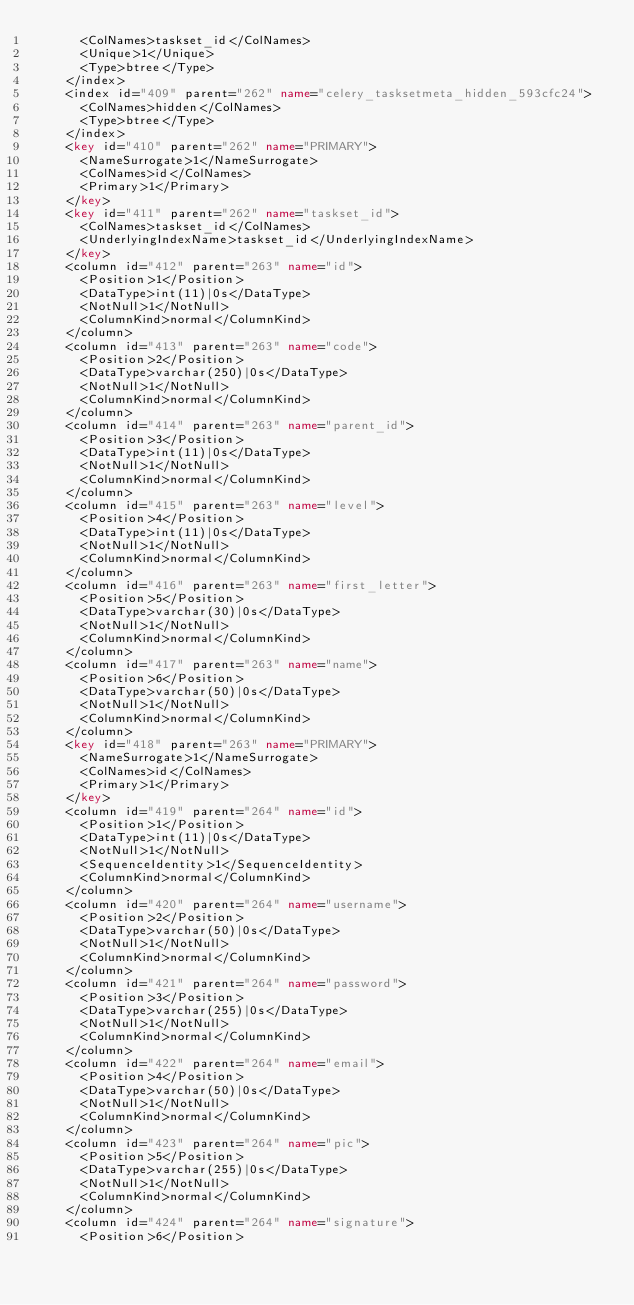Convert code to text. <code><loc_0><loc_0><loc_500><loc_500><_XML_>      <ColNames>taskset_id</ColNames>
      <Unique>1</Unique>
      <Type>btree</Type>
    </index>
    <index id="409" parent="262" name="celery_tasksetmeta_hidden_593cfc24">
      <ColNames>hidden</ColNames>
      <Type>btree</Type>
    </index>
    <key id="410" parent="262" name="PRIMARY">
      <NameSurrogate>1</NameSurrogate>
      <ColNames>id</ColNames>
      <Primary>1</Primary>
    </key>
    <key id="411" parent="262" name="taskset_id">
      <ColNames>taskset_id</ColNames>
      <UnderlyingIndexName>taskset_id</UnderlyingIndexName>
    </key>
    <column id="412" parent="263" name="id">
      <Position>1</Position>
      <DataType>int(11)|0s</DataType>
      <NotNull>1</NotNull>
      <ColumnKind>normal</ColumnKind>
    </column>
    <column id="413" parent="263" name="code">
      <Position>2</Position>
      <DataType>varchar(250)|0s</DataType>
      <NotNull>1</NotNull>
      <ColumnKind>normal</ColumnKind>
    </column>
    <column id="414" parent="263" name="parent_id">
      <Position>3</Position>
      <DataType>int(11)|0s</DataType>
      <NotNull>1</NotNull>
      <ColumnKind>normal</ColumnKind>
    </column>
    <column id="415" parent="263" name="level">
      <Position>4</Position>
      <DataType>int(11)|0s</DataType>
      <NotNull>1</NotNull>
      <ColumnKind>normal</ColumnKind>
    </column>
    <column id="416" parent="263" name="first_letter">
      <Position>5</Position>
      <DataType>varchar(30)|0s</DataType>
      <NotNull>1</NotNull>
      <ColumnKind>normal</ColumnKind>
    </column>
    <column id="417" parent="263" name="name">
      <Position>6</Position>
      <DataType>varchar(50)|0s</DataType>
      <NotNull>1</NotNull>
      <ColumnKind>normal</ColumnKind>
    </column>
    <key id="418" parent="263" name="PRIMARY">
      <NameSurrogate>1</NameSurrogate>
      <ColNames>id</ColNames>
      <Primary>1</Primary>
    </key>
    <column id="419" parent="264" name="id">
      <Position>1</Position>
      <DataType>int(11)|0s</DataType>
      <NotNull>1</NotNull>
      <SequenceIdentity>1</SequenceIdentity>
      <ColumnKind>normal</ColumnKind>
    </column>
    <column id="420" parent="264" name="username">
      <Position>2</Position>
      <DataType>varchar(50)|0s</DataType>
      <NotNull>1</NotNull>
      <ColumnKind>normal</ColumnKind>
    </column>
    <column id="421" parent="264" name="password">
      <Position>3</Position>
      <DataType>varchar(255)|0s</DataType>
      <NotNull>1</NotNull>
      <ColumnKind>normal</ColumnKind>
    </column>
    <column id="422" parent="264" name="email">
      <Position>4</Position>
      <DataType>varchar(50)|0s</DataType>
      <NotNull>1</NotNull>
      <ColumnKind>normal</ColumnKind>
    </column>
    <column id="423" parent="264" name="pic">
      <Position>5</Position>
      <DataType>varchar(255)|0s</DataType>
      <NotNull>1</NotNull>
      <ColumnKind>normal</ColumnKind>
    </column>
    <column id="424" parent="264" name="signature">
      <Position>6</Position></code> 